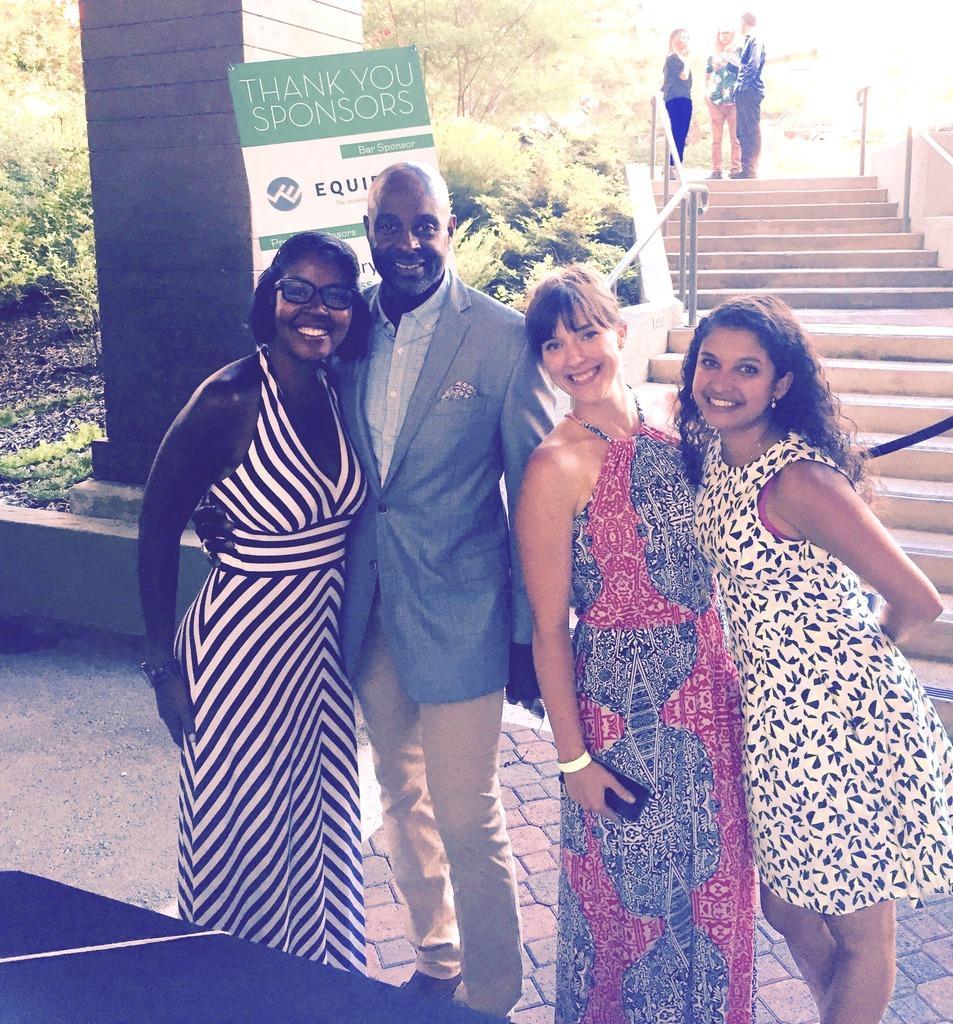Can you describe this image briefly? In this image there are people and we can see stairs. On the left there is a board and we can see a pillar. There are trees. 